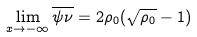Convert formula to latex. <formula><loc_0><loc_0><loc_500><loc_500>\lim _ { x \to - \infty } \overline { \psi \nu } = 2 \rho _ { 0 } ( \sqrt { \rho _ { 0 } } - 1 )</formula> 